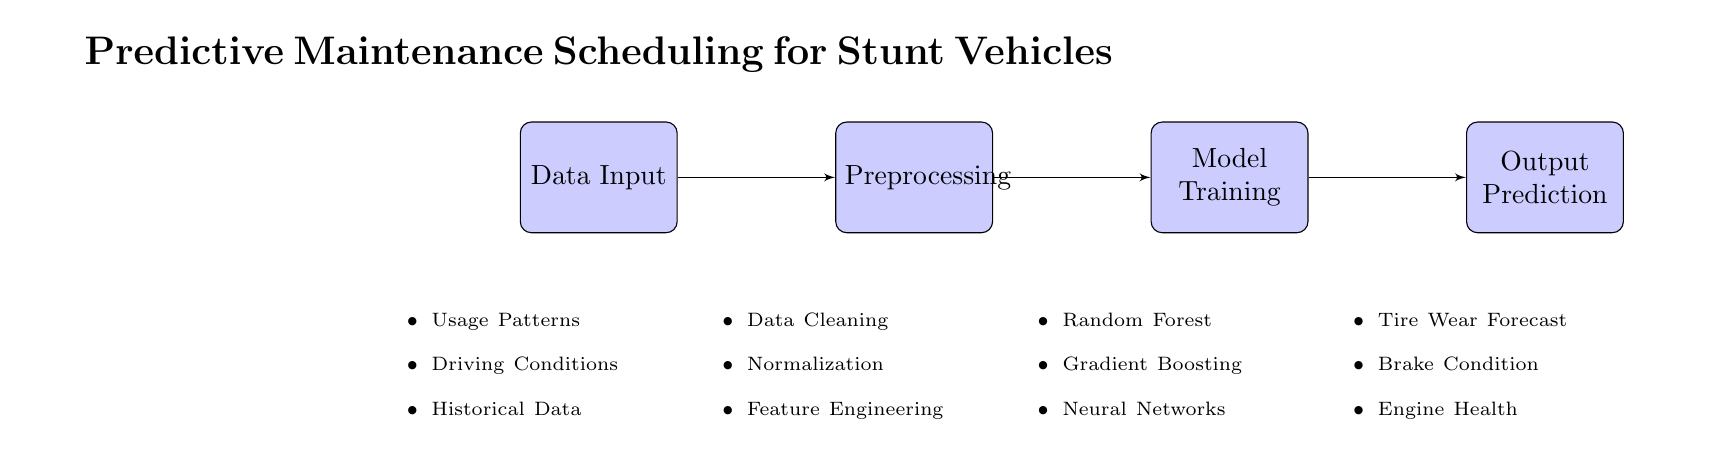What are the input data types listed in the diagram? The diagram specifies three types of input data: Usage Patterns, Driving Conditions, and Historical Data. These are listed in the 'Data Input' node's details.
Answer: Usage Patterns, Driving Conditions, Historical Data What is the last node in the flow of this diagram? The flow of the diagram leads through four nodes: Data Input, Preprocessing, Model Training, and concludes with the Output Prediction node, which is the last one.
Answer: Output Prediction How many preprocessing steps are indicated in the diagram? Under the 'Preprocessing' node, three steps are enumerated: Data Cleaning, Normalization, and Feature Engineering, making the total count three.
Answer: 3 Which model types are mentioned in the Model Training step? The 'Model Training' node details three model types: Random Forest, Gradient Boosting, and Neural Networks, showing the approaches taken to train the predictive model.
Answer: Random Forest, Gradient Boosting, Neural Networks What are the three aspects predicted in the Output Prediction layer? The diagram outlines three aspects being predicted in the 'Output Prediction' layer: Tire Wear Forecast, Brake Condition, and Engine Health, giving a clear focus on maintenance outputs.
Answer: Tire Wear Forecast, Brake Condition, Engine Health What type of diagram is represented? The diagram shows a structured flow combining data input, preprocessing, model training, and output in a linear format, signifying it is a Machine Learning Diagram specifically for predictive maintenance scheduling.
Answer: Machine Learning Diagram What process follows after the preprocessing step? Following the preprocessing step in the diagram, the next step is the Model Training phase, where the prepared data is utilized to develop predictive models.
Answer: Model Training How is the data organized in this diagram? The data is organized in a sequential flow starting with data input, followed by preprocessing, then model training, and culminating in output prediction, demonstrating a clear processing pipeline.
Answer: Sequential flow 